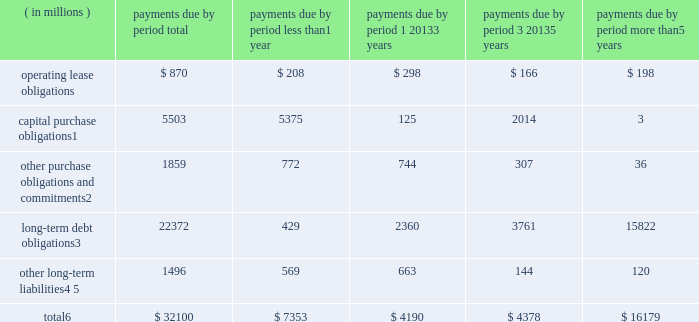Contractual obligations the table summarizes our significant contractual obligations as of december 28 , 2013: .
Capital purchase obligations1 5503 5375 125 2014 3 other purchase obligations and commitments2 1859 772 744 307 36 long-term debt obligations3 22372 429 2360 3761 15822 other long-term liabilities4 , 5 1496 569 663 144 120 total6 $ 32100 $ 7353 $ 4190 $ 4378 $ 16179 1 capital purchase obligations represent commitments for the construction or purchase of property , plant and equipment .
They were not recorded as liabilities on our consolidated balance sheets as of december 28 , 2013 , as we had not yet received the related goods or taken title to the property .
2 other purchase obligations and commitments include payments due under various types of licenses and agreements to purchase goods or services , as well as payments due under non-contingent funding obligations .
Funding obligations include agreements to fund various projects with other companies .
3 amounts represent principal and interest cash payments over the life of the debt obligations , including anticipated interest payments that are not recorded on our consolidated balance sheets .
Any future settlement of convertible debt would impact our cash payments .
4 we are unable to reliably estimate the timing of future payments related to uncertain tax positions ; therefore , $ 188 million of long-term income taxes payable has been excluded from the preceding table .
However , long- term income taxes payable , recorded on our consolidated balance sheets , included these uncertain tax positions , reduced by the associated federal deduction for state taxes and u.s .
Tax credits arising from non- u.s .
Income taxes .
5 amounts represent future cash payments to satisfy other long-term liabilities recorded on our consolidated balance sheets , including the short-term portion of these long-term liabilities .
Expected required contributions to our u.s .
And non-u.s .
Pension plans and other postretirement benefit plans of $ 62 million to be made during 2014 are also included ; however , funding projections beyond 2014 are not practicable to estimate .
6 total excludes contractual obligations already recorded on our consolidated balance sheets as current liabilities except for the short-term portions of long-term debt obligations and other long-term liabilities .
Contractual obligations for purchases of goods or services , included in other purchase obligations and commitments in the preceding table , include agreements that are enforceable and legally binding on intel and that specify all significant terms , including fixed or minimum quantities to be purchased ; fixed , minimum , or variable price provisions ; and the approximate timing of the transaction .
For obligations with cancellation provisions , the amounts included in the preceding table were limited to the non-cancelable portion of the agreement terms or the minimum cancellation fee .
We have entered into certain agreements for the purchase of raw materials that specify minimum prices and quantities based on a percentage of the total available market or based on a percentage of our future purchasing requirements .
Due to the uncertainty of the future market and our future purchasing requirements , as well as the non-binding nature of these agreements , obligations under these agreements are not included in the preceding table .
Our purchase orders for other products are based on our current manufacturing needs and are fulfilled by our vendors within short time horizons .
In addition , some of our purchase orders represent authorizations to purchase rather than binding agreements .
Table of contents management 2019s discussion and analysis of financial condition and results of operations ( continued ) .
What was the percent of the pension plans and other post retirement benefit plans included in the total other long-term liabilities as of december 28 , 2013? 
Rationale: as of december 28 , 2013 the total other long-term liabilities included 4.1% of pension plans and other post retirement benefit plans
Computations: (62 / 1496)
Answer: 0.04144. 